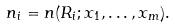Convert formula to latex. <formula><loc_0><loc_0><loc_500><loc_500>n _ { i } = n ( R _ { i } ; x _ { 1 } , \dots , x _ { m } ) .</formula> 